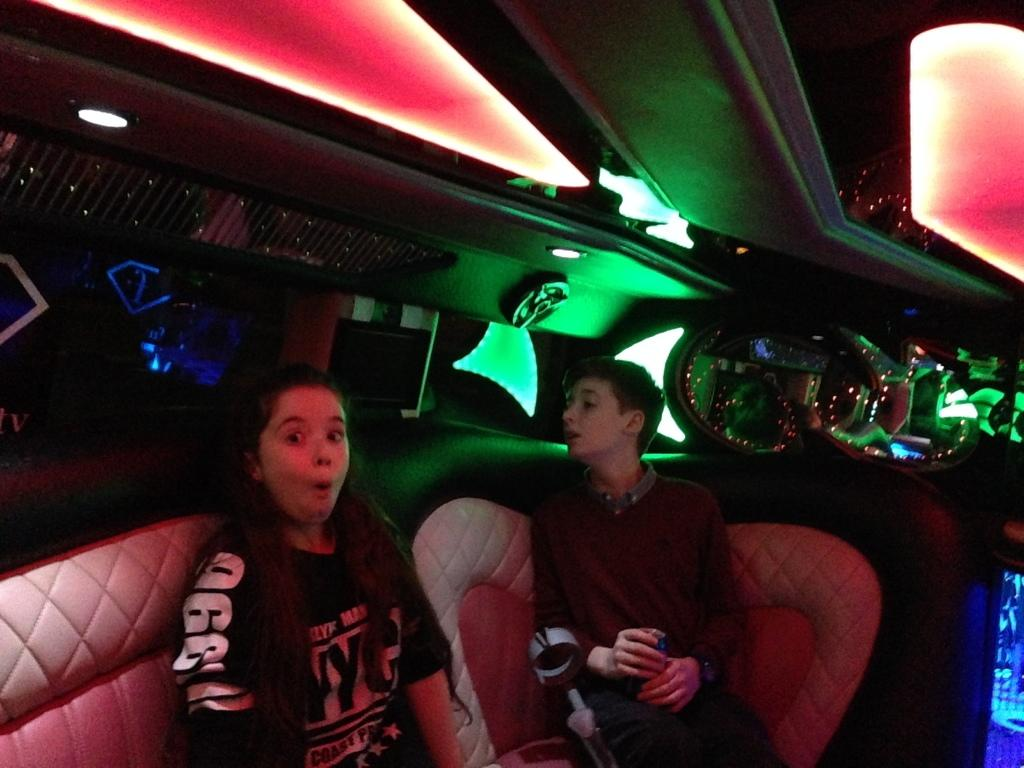How many people are in the image? There are two people in the image. Can you describe the individuals in the image? One of them is a girl, and the other one is a boy. What are the positions of the girl and the boy in the image? Both the girl and the boy are sitting on sofas. What colors of lights can be seen in the background of the image? There are green, red, and blue color lights in the background. What type of disgusting tin can be seen in the image? There is no tin, let alone a disgusting one, present in the image. 